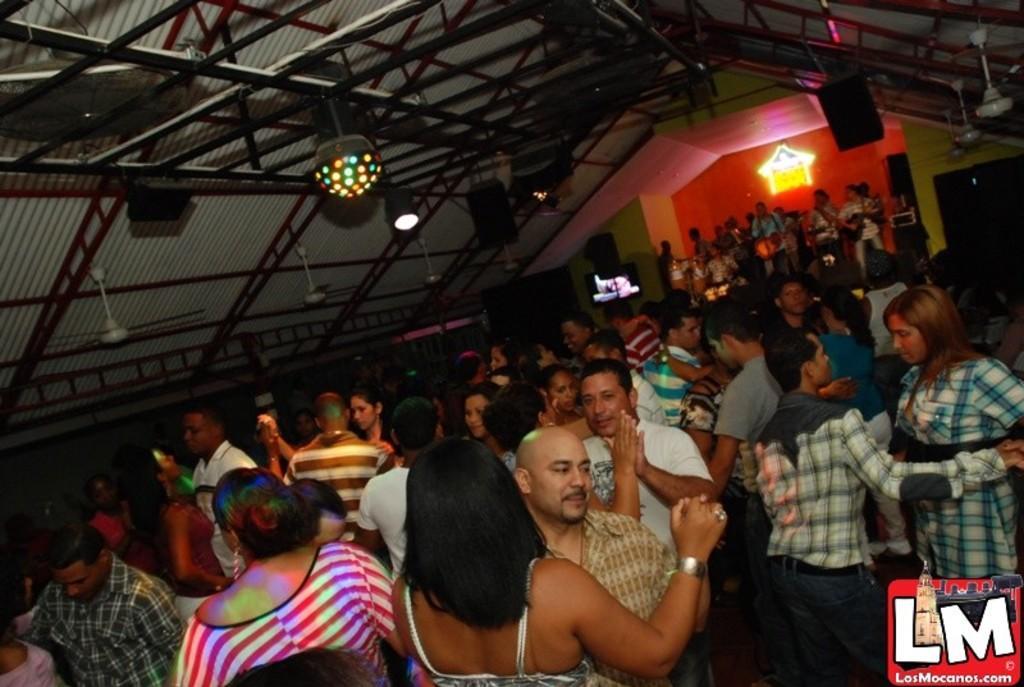In one or two sentences, can you explain what this image depicts? In this image there are a few people dancing inside a hall. 